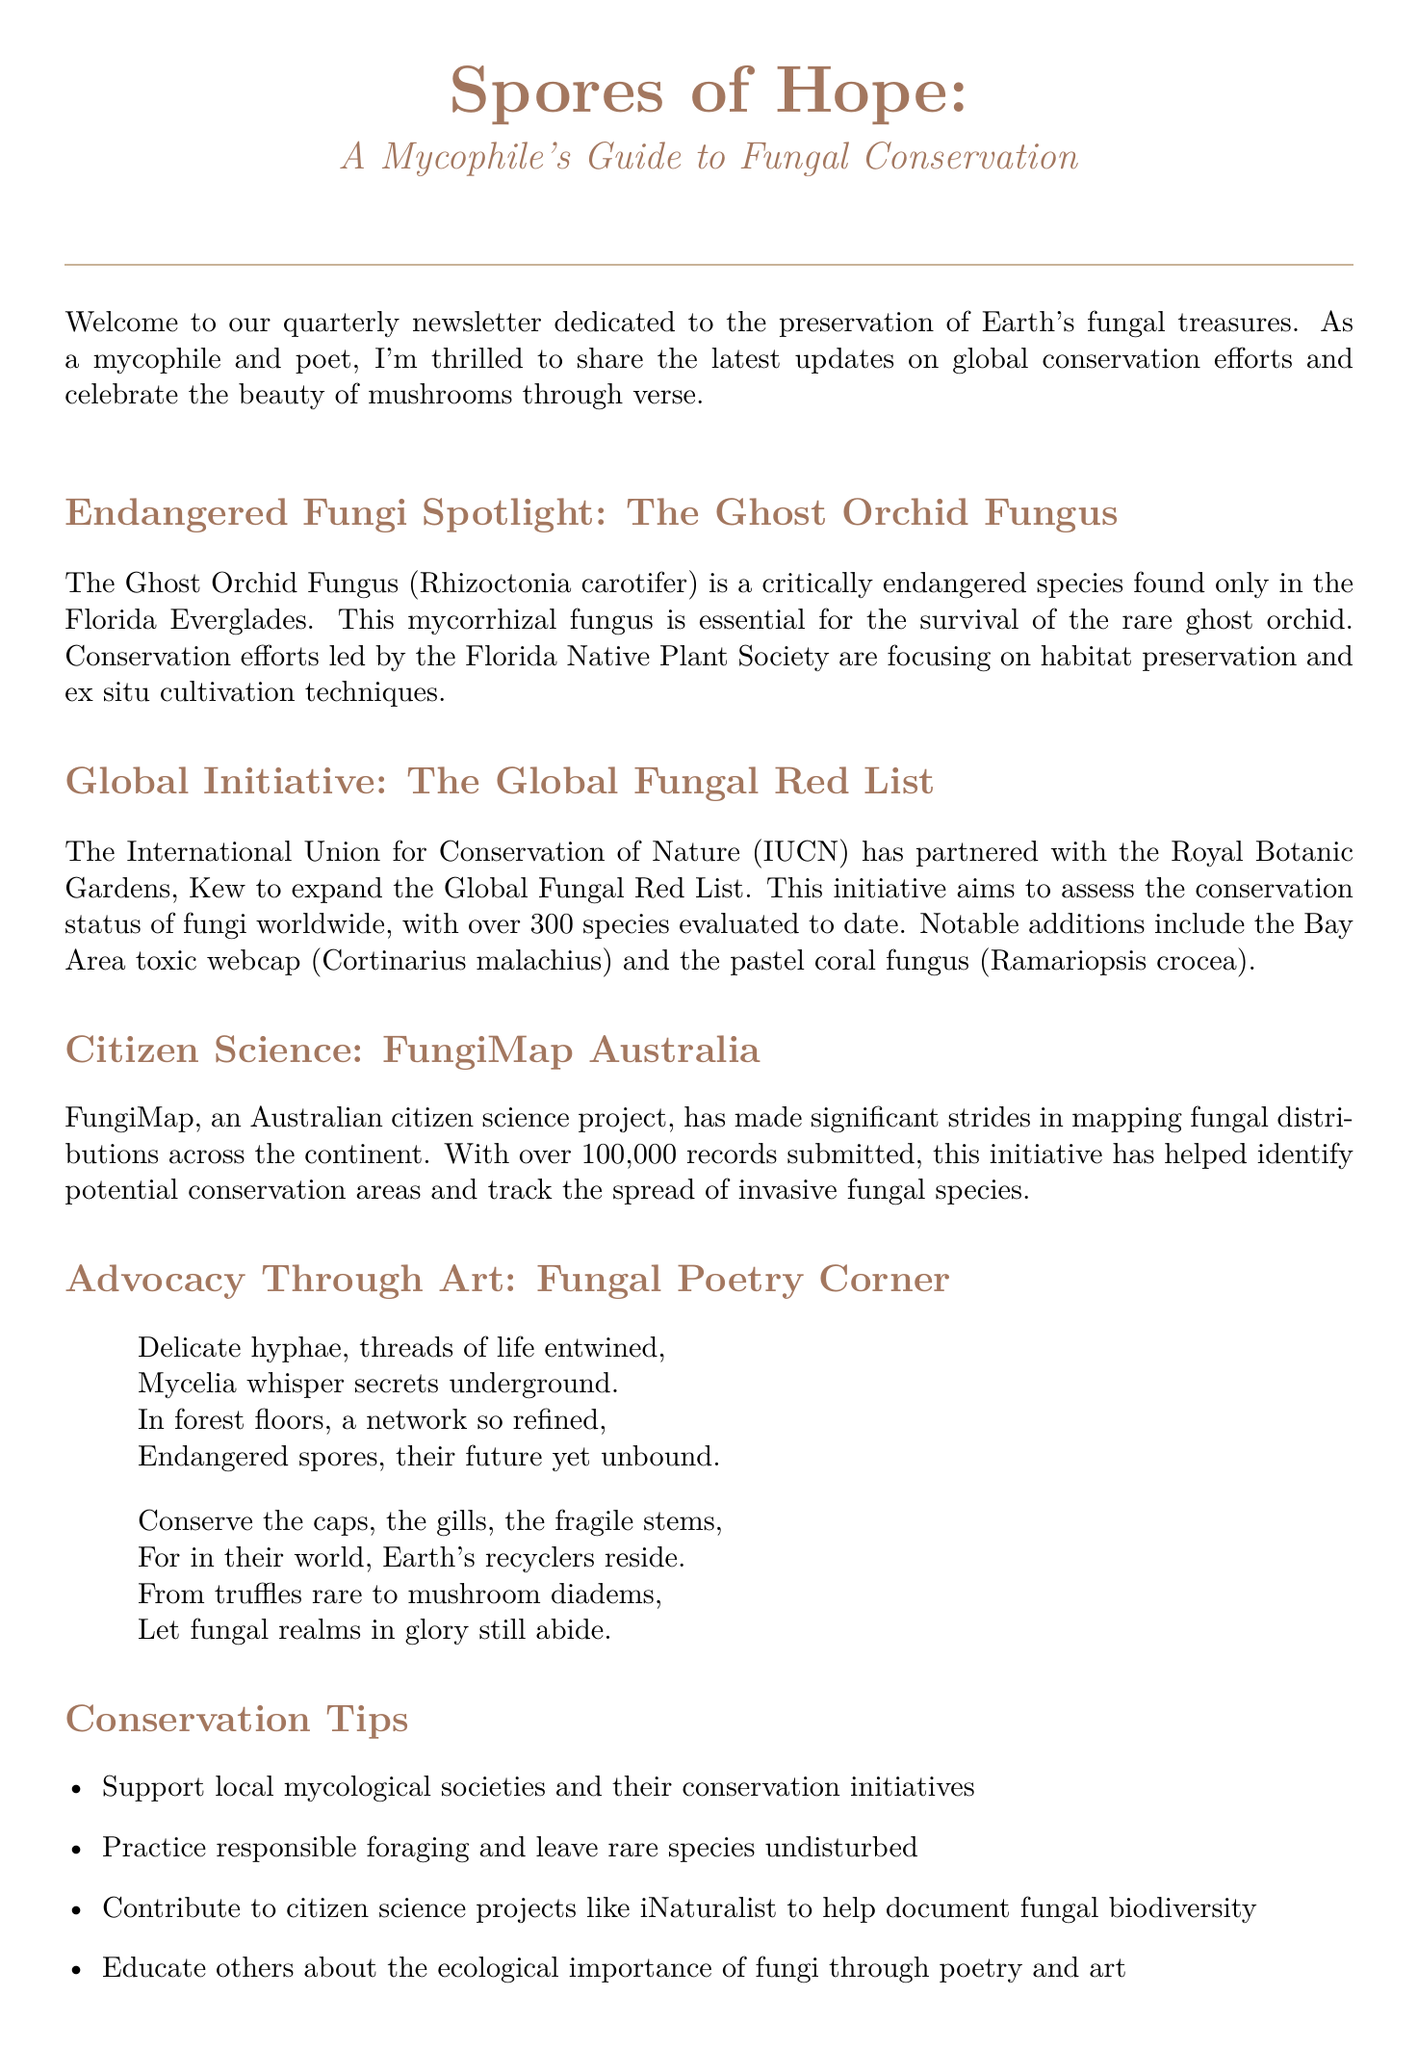What is the title of the newsletter? The title appears at the top of the document, providing the main theme of the newsletter.
Answer: Spores of Hope: A Mycophile's Guide to Fungal Conservation Which fungus is highlighted in the Endangered Fungi Spotlight? The specific fungus mentioned in the spotlight section indicates its critical conservation status.
Answer: The Ghost Orchid Fungus What organization is leading the conservation efforts for the Ghost Orchid Fungus? The document identifies the organization involved in conservation efforts for this endangered species.
Answer: Florida Native Plant Society How many species has the Global Fungal Red List assessed to date? The number of species evaluated in the initiative is a key statistic in the document.
Answer: Over 300 species What is the name of the Australian citizen science project mentioned? This project is specifically focused on mapping fungal distributions in Australia, which is detailed in the document.
Answer: FungiMap Australia What is one conservation tip mentioned in the newsletter? The document lists practical conservation tips that readers can follow, focusing on responsible actions.
Answer: Support local mycological societies and their conservation initiatives When is the North American Mycological Association Annual Foray taking place? The date for this upcoming event is provided in the document, informing readers about participation opportunities.
Answer: September 15-18, 2023 Who is the author of the featured book? The author of the recommended book is mentioned, providing insight into reputable sources in the field of mycology.
Answer: Merlin Sheldrake 